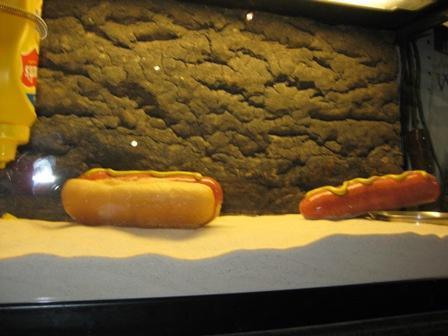How many hot dogs are there?
Give a very brief answer. 2. 